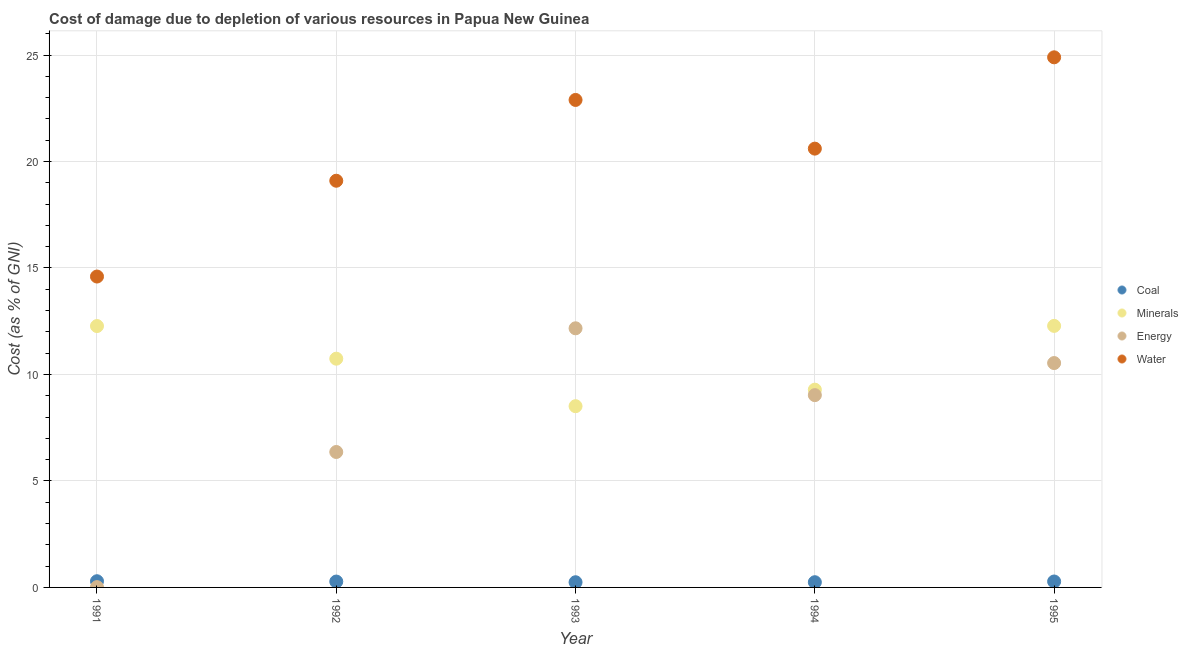What is the cost of damage due to depletion of coal in 1995?
Offer a terse response. 0.28. Across all years, what is the maximum cost of damage due to depletion of water?
Your response must be concise. 24.89. Across all years, what is the minimum cost of damage due to depletion of minerals?
Give a very brief answer. 8.51. What is the total cost of damage due to depletion of energy in the graph?
Provide a succinct answer. 38.11. What is the difference between the cost of damage due to depletion of coal in 1992 and that in 1994?
Provide a short and direct response. 0.03. What is the difference between the cost of damage due to depletion of minerals in 1993 and the cost of damage due to depletion of water in 1991?
Offer a very short reply. -6.09. What is the average cost of damage due to depletion of coal per year?
Your answer should be compact. 0.27. In the year 1994, what is the difference between the cost of damage due to depletion of water and cost of damage due to depletion of coal?
Give a very brief answer. 20.36. What is the ratio of the cost of damage due to depletion of minerals in 1991 to that in 1995?
Keep it short and to the point. 1. Is the difference between the cost of damage due to depletion of water in 1994 and 1995 greater than the difference between the cost of damage due to depletion of minerals in 1994 and 1995?
Your answer should be very brief. No. What is the difference between the highest and the second highest cost of damage due to depletion of minerals?
Your answer should be compact. 0.01. What is the difference between the highest and the lowest cost of damage due to depletion of water?
Your answer should be very brief. 10.29. Is the sum of the cost of damage due to depletion of coal in 1993 and 1994 greater than the maximum cost of damage due to depletion of minerals across all years?
Offer a very short reply. No. Is it the case that in every year, the sum of the cost of damage due to depletion of coal and cost of damage due to depletion of minerals is greater than the cost of damage due to depletion of energy?
Your response must be concise. No. Is the cost of damage due to depletion of coal strictly greater than the cost of damage due to depletion of water over the years?
Provide a short and direct response. No. Is the cost of damage due to depletion of minerals strictly less than the cost of damage due to depletion of coal over the years?
Ensure brevity in your answer.  No. How many dotlines are there?
Your answer should be very brief. 4. How many years are there in the graph?
Offer a very short reply. 5. What is the difference between two consecutive major ticks on the Y-axis?
Offer a very short reply. 5. Are the values on the major ticks of Y-axis written in scientific E-notation?
Make the answer very short. No. Does the graph contain any zero values?
Your response must be concise. No. Does the graph contain grids?
Offer a terse response. Yes. How many legend labels are there?
Provide a short and direct response. 4. What is the title of the graph?
Provide a succinct answer. Cost of damage due to depletion of various resources in Papua New Guinea . Does "Corruption" appear as one of the legend labels in the graph?
Offer a very short reply. No. What is the label or title of the X-axis?
Keep it short and to the point. Year. What is the label or title of the Y-axis?
Provide a short and direct response. Cost (as % of GNI). What is the Cost (as % of GNI) in Coal in 1991?
Offer a terse response. 0.29. What is the Cost (as % of GNI) of Minerals in 1991?
Provide a succinct answer. 12.27. What is the Cost (as % of GNI) in Energy in 1991?
Ensure brevity in your answer.  0.01. What is the Cost (as % of GNI) in Water in 1991?
Provide a short and direct response. 14.6. What is the Cost (as % of GNI) of Coal in 1992?
Offer a very short reply. 0.28. What is the Cost (as % of GNI) of Minerals in 1992?
Ensure brevity in your answer.  10.74. What is the Cost (as % of GNI) of Energy in 1992?
Offer a very short reply. 6.36. What is the Cost (as % of GNI) of Water in 1992?
Keep it short and to the point. 19.1. What is the Cost (as % of GNI) of Coal in 1993?
Your response must be concise. 0.24. What is the Cost (as % of GNI) of Minerals in 1993?
Your response must be concise. 8.51. What is the Cost (as % of GNI) of Energy in 1993?
Keep it short and to the point. 12.17. What is the Cost (as % of GNI) of Water in 1993?
Provide a succinct answer. 22.89. What is the Cost (as % of GNI) in Coal in 1994?
Provide a succinct answer. 0.24. What is the Cost (as % of GNI) of Minerals in 1994?
Your answer should be very brief. 9.29. What is the Cost (as % of GNI) in Energy in 1994?
Make the answer very short. 9.03. What is the Cost (as % of GNI) in Water in 1994?
Keep it short and to the point. 20.6. What is the Cost (as % of GNI) in Coal in 1995?
Offer a terse response. 0.28. What is the Cost (as % of GNI) in Minerals in 1995?
Offer a very short reply. 12.28. What is the Cost (as % of GNI) of Energy in 1995?
Ensure brevity in your answer.  10.54. What is the Cost (as % of GNI) of Water in 1995?
Give a very brief answer. 24.89. Across all years, what is the maximum Cost (as % of GNI) in Coal?
Your response must be concise. 0.29. Across all years, what is the maximum Cost (as % of GNI) of Minerals?
Your answer should be very brief. 12.28. Across all years, what is the maximum Cost (as % of GNI) of Energy?
Your answer should be very brief. 12.17. Across all years, what is the maximum Cost (as % of GNI) of Water?
Keep it short and to the point. 24.89. Across all years, what is the minimum Cost (as % of GNI) of Coal?
Give a very brief answer. 0.24. Across all years, what is the minimum Cost (as % of GNI) of Minerals?
Provide a succinct answer. 8.51. Across all years, what is the minimum Cost (as % of GNI) in Energy?
Offer a terse response. 0.01. Across all years, what is the minimum Cost (as % of GNI) in Water?
Provide a short and direct response. 14.6. What is the total Cost (as % of GNI) of Coal in the graph?
Provide a succinct answer. 1.33. What is the total Cost (as % of GNI) in Minerals in the graph?
Ensure brevity in your answer.  53.09. What is the total Cost (as % of GNI) in Energy in the graph?
Provide a succinct answer. 38.11. What is the total Cost (as % of GNI) of Water in the graph?
Offer a terse response. 102.08. What is the difference between the Cost (as % of GNI) in Coal in 1991 and that in 1992?
Your answer should be compact. 0.02. What is the difference between the Cost (as % of GNI) in Minerals in 1991 and that in 1992?
Make the answer very short. 1.53. What is the difference between the Cost (as % of GNI) of Energy in 1991 and that in 1992?
Give a very brief answer. -6.34. What is the difference between the Cost (as % of GNI) of Water in 1991 and that in 1992?
Provide a succinct answer. -4.5. What is the difference between the Cost (as % of GNI) of Coal in 1991 and that in 1993?
Keep it short and to the point. 0.05. What is the difference between the Cost (as % of GNI) of Minerals in 1991 and that in 1993?
Offer a very short reply. 3.76. What is the difference between the Cost (as % of GNI) in Energy in 1991 and that in 1993?
Keep it short and to the point. -12.15. What is the difference between the Cost (as % of GNI) in Water in 1991 and that in 1993?
Ensure brevity in your answer.  -8.29. What is the difference between the Cost (as % of GNI) in Coal in 1991 and that in 1994?
Offer a very short reply. 0.05. What is the difference between the Cost (as % of GNI) in Minerals in 1991 and that in 1994?
Ensure brevity in your answer.  2.99. What is the difference between the Cost (as % of GNI) in Energy in 1991 and that in 1994?
Offer a terse response. -9.01. What is the difference between the Cost (as % of GNI) in Water in 1991 and that in 1994?
Ensure brevity in your answer.  -6.01. What is the difference between the Cost (as % of GNI) in Coal in 1991 and that in 1995?
Ensure brevity in your answer.  0.01. What is the difference between the Cost (as % of GNI) in Minerals in 1991 and that in 1995?
Offer a very short reply. -0.01. What is the difference between the Cost (as % of GNI) in Energy in 1991 and that in 1995?
Keep it short and to the point. -10.52. What is the difference between the Cost (as % of GNI) of Water in 1991 and that in 1995?
Ensure brevity in your answer.  -10.29. What is the difference between the Cost (as % of GNI) of Coal in 1992 and that in 1993?
Make the answer very short. 0.03. What is the difference between the Cost (as % of GNI) in Minerals in 1992 and that in 1993?
Your answer should be very brief. 2.23. What is the difference between the Cost (as % of GNI) of Energy in 1992 and that in 1993?
Your answer should be compact. -5.81. What is the difference between the Cost (as % of GNI) of Water in 1992 and that in 1993?
Offer a terse response. -3.79. What is the difference between the Cost (as % of GNI) of Coal in 1992 and that in 1994?
Your answer should be very brief. 0.03. What is the difference between the Cost (as % of GNI) in Minerals in 1992 and that in 1994?
Provide a short and direct response. 1.45. What is the difference between the Cost (as % of GNI) in Energy in 1992 and that in 1994?
Provide a succinct answer. -2.67. What is the difference between the Cost (as % of GNI) of Water in 1992 and that in 1994?
Your answer should be compact. -1.51. What is the difference between the Cost (as % of GNI) of Coal in 1992 and that in 1995?
Your response must be concise. -0. What is the difference between the Cost (as % of GNI) in Minerals in 1992 and that in 1995?
Your response must be concise. -1.54. What is the difference between the Cost (as % of GNI) in Energy in 1992 and that in 1995?
Your answer should be very brief. -4.18. What is the difference between the Cost (as % of GNI) in Water in 1992 and that in 1995?
Your response must be concise. -5.8. What is the difference between the Cost (as % of GNI) of Coal in 1993 and that in 1994?
Your answer should be compact. -0. What is the difference between the Cost (as % of GNI) in Minerals in 1993 and that in 1994?
Give a very brief answer. -0.78. What is the difference between the Cost (as % of GNI) in Energy in 1993 and that in 1994?
Offer a very short reply. 3.14. What is the difference between the Cost (as % of GNI) of Water in 1993 and that in 1994?
Make the answer very short. 2.29. What is the difference between the Cost (as % of GNI) of Coal in 1993 and that in 1995?
Provide a succinct answer. -0.04. What is the difference between the Cost (as % of GNI) of Minerals in 1993 and that in 1995?
Keep it short and to the point. -3.77. What is the difference between the Cost (as % of GNI) in Energy in 1993 and that in 1995?
Ensure brevity in your answer.  1.63. What is the difference between the Cost (as % of GNI) in Water in 1993 and that in 1995?
Keep it short and to the point. -2. What is the difference between the Cost (as % of GNI) in Coal in 1994 and that in 1995?
Keep it short and to the point. -0.03. What is the difference between the Cost (as % of GNI) of Minerals in 1994 and that in 1995?
Keep it short and to the point. -2.99. What is the difference between the Cost (as % of GNI) of Energy in 1994 and that in 1995?
Provide a succinct answer. -1.51. What is the difference between the Cost (as % of GNI) of Water in 1994 and that in 1995?
Your answer should be very brief. -4.29. What is the difference between the Cost (as % of GNI) of Coal in 1991 and the Cost (as % of GNI) of Minerals in 1992?
Keep it short and to the point. -10.45. What is the difference between the Cost (as % of GNI) of Coal in 1991 and the Cost (as % of GNI) of Energy in 1992?
Provide a succinct answer. -6.07. What is the difference between the Cost (as % of GNI) in Coal in 1991 and the Cost (as % of GNI) in Water in 1992?
Your answer should be compact. -18.8. What is the difference between the Cost (as % of GNI) of Minerals in 1991 and the Cost (as % of GNI) of Energy in 1992?
Offer a very short reply. 5.91. What is the difference between the Cost (as % of GNI) of Minerals in 1991 and the Cost (as % of GNI) of Water in 1992?
Keep it short and to the point. -6.82. What is the difference between the Cost (as % of GNI) in Energy in 1991 and the Cost (as % of GNI) in Water in 1992?
Make the answer very short. -19.08. What is the difference between the Cost (as % of GNI) of Coal in 1991 and the Cost (as % of GNI) of Minerals in 1993?
Give a very brief answer. -8.22. What is the difference between the Cost (as % of GNI) of Coal in 1991 and the Cost (as % of GNI) of Energy in 1993?
Your answer should be compact. -11.88. What is the difference between the Cost (as % of GNI) in Coal in 1991 and the Cost (as % of GNI) in Water in 1993?
Offer a very short reply. -22.6. What is the difference between the Cost (as % of GNI) in Minerals in 1991 and the Cost (as % of GNI) in Energy in 1993?
Your answer should be very brief. 0.11. What is the difference between the Cost (as % of GNI) in Minerals in 1991 and the Cost (as % of GNI) in Water in 1993?
Provide a short and direct response. -10.62. What is the difference between the Cost (as % of GNI) of Energy in 1991 and the Cost (as % of GNI) of Water in 1993?
Make the answer very short. -22.88. What is the difference between the Cost (as % of GNI) in Coal in 1991 and the Cost (as % of GNI) in Minerals in 1994?
Make the answer very short. -9. What is the difference between the Cost (as % of GNI) in Coal in 1991 and the Cost (as % of GNI) in Energy in 1994?
Your response must be concise. -8.74. What is the difference between the Cost (as % of GNI) of Coal in 1991 and the Cost (as % of GNI) of Water in 1994?
Keep it short and to the point. -20.31. What is the difference between the Cost (as % of GNI) of Minerals in 1991 and the Cost (as % of GNI) of Energy in 1994?
Your answer should be compact. 3.24. What is the difference between the Cost (as % of GNI) in Minerals in 1991 and the Cost (as % of GNI) in Water in 1994?
Make the answer very short. -8.33. What is the difference between the Cost (as % of GNI) in Energy in 1991 and the Cost (as % of GNI) in Water in 1994?
Ensure brevity in your answer.  -20.59. What is the difference between the Cost (as % of GNI) of Coal in 1991 and the Cost (as % of GNI) of Minerals in 1995?
Offer a very short reply. -11.99. What is the difference between the Cost (as % of GNI) of Coal in 1991 and the Cost (as % of GNI) of Energy in 1995?
Make the answer very short. -10.24. What is the difference between the Cost (as % of GNI) of Coal in 1991 and the Cost (as % of GNI) of Water in 1995?
Offer a very short reply. -24.6. What is the difference between the Cost (as % of GNI) in Minerals in 1991 and the Cost (as % of GNI) in Energy in 1995?
Give a very brief answer. 1.74. What is the difference between the Cost (as % of GNI) of Minerals in 1991 and the Cost (as % of GNI) of Water in 1995?
Provide a short and direct response. -12.62. What is the difference between the Cost (as % of GNI) of Energy in 1991 and the Cost (as % of GNI) of Water in 1995?
Offer a terse response. -24.88. What is the difference between the Cost (as % of GNI) of Coal in 1992 and the Cost (as % of GNI) of Minerals in 1993?
Offer a terse response. -8.23. What is the difference between the Cost (as % of GNI) of Coal in 1992 and the Cost (as % of GNI) of Energy in 1993?
Offer a very short reply. -11.89. What is the difference between the Cost (as % of GNI) in Coal in 1992 and the Cost (as % of GNI) in Water in 1993?
Offer a very short reply. -22.61. What is the difference between the Cost (as % of GNI) in Minerals in 1992 and the Cost (as % of GNI) in Energy in 1993?
Offer a terse response. -1.43. What is the difference between the Cost (as % of GNI) of Minerals in 1992 and the Cost (as % of GNI) of Water in 1993?
Offer a terse response. -12.15. What is the difference between the Cost (as % of GNI) in Energy in 1992 and the Cost (as % of GNI) in Water in 1993?
Ensure brevity in your answer.  -16.53. What is the difference between the Cost (as % of GNI) in Coal in 1992 and the Cost (as % of GNI) in Minerals in 1994?
Make the answer very short. -9.01. What is the difference between the Cost (as % of GNI) of Coal in 1992 and the Cost (as % of GNI) of Energy in 1994?
Offer a terse response. -8.75. What is the difference between the Cost (as % of GNI) in Coal in 1992 and the Cost (as % of GNI) in Water in 1994?
Offer a very short reply. -20.33. What is the difference between the Cost (as % of GNI) of Minerals in 1992 and the Cost (as % of GNI) of Energy in 1994?
Your response must be concise. 1.71. What is the difference between the Cost (as % of GNI) of Minerals in 1992 and the Cost (as % of GNI) of Water in 1994?
Provide a short and direct response. -9.86. What is the difference between the Cost (as % of GNI) of Energy in 1992 and the Cost (as % of GNI) of Water in 1994?
Your response must be concise. -14.24. What is the difference between the Cost (as % of GNI) in Coal in 1992 and the Cost (as % of GNI) in Minerals in 1995?
Give a very brief answer. -12. What is the difference between the Cost (as % of GNI) of Coal in 1992 and the Cost (as % of GNI) of Energy in 1995?
Your answer should be very brief. -10.26. What is the difference between the Cost (as % of GNI) of Coal in 1992 and the Cost (as % of GNI) of Water in 1995?
Offer a terse response. -24.62. What is the difference between the Cost (as % of GNI) of Minerals in 1992 and the Cost (as % of GNI) of Energy in 1995?
Your answer should be compact. 0.21. What is the difference between the Cost (as % of GNI) in Minerals in 1992 and the Cost (as % of GNI) in Water in 1995?
Provide a succinct answer. -14.15. What is the difference between the Cost (as % of GNI) in Energy in 1992 and the Cost (as % of GNI) in Water in 1995?
Give a very brief answer. -18.53. What is the difference between the Cost (as % of GNI) of Coal in 1993 and the Cost (as % of GNI) of Minerals in 1994?
Your response must be concise. -9.04. What is the difference between the Cost (as % of GNI) of Coal in 1993 and the Cost (as % of GNI) of Energy in 1994?
Ensure brevity in your answer.  -8.79. What is the difference between the Cost (as % of GNI) in Coal in 1993 and the Cost (as % of GNI) in Water in 1994?
Your answer should be compact. -20.36. What is the difference between the Cost (as % of GNI) of Minerals in 1993 and the Cost (as % of GNI) of Energy in 1994?
Your answer should be compact. -0.52. What is the difference between the Cost (as % of GNI) in Minerals in 1993 and the Cost (as % of GNI) in Water in 1994?
Provide a short and direct response. -12.09. What is the difference between the Cost (as % of GNI) of Energy in 1993 and the Cost (as % of GNI) of Water in 1994?
Your answer should be very brief. -8.44. What is the difference between the Cost (as % of GNI) in Coal in 1993 and the Cost (as % of GNI) in Minerals in 1995?
Give a very brief answer. -12.04. What is the difference between the Cost (as % of GNI) of Coal in 1993 and the Cost (as % of GNI) of Energy in 1995?
Keep it short and to the point. -10.29. What is the difference between the Cost (as % of GNI) in Coal in 1993 and the Cost (as % of GNI) in Water in 1995?
Offer a terse response. -24.65. What is the difference between the Cost (as % of GNI) of Minerals in 1993 and the Cost (as % of GNI) of Energy in 1995?
Your answer should be compact. -2.02. What is the difference between the Cost (as % of GNI) of Minerals in 1993 and the Cost (as % of GNI) of Water in 1995?
Your response must be concise. -16.38. What is the difference between the Cost (as % of GNI) in Energy in 1993 and the Cost (as % of GNI) in Water in 1995?
Make the answer very short. -12.72. What is the difference between the Cost (as % of GNI) of Coal in 1994 and the Cost (as % of GNI) of Minerals in 1995?
Provide a short and direct response. -12.04. What is the difference between the Cost (as % of GNI) of Coal in 1994 and the Cost (as % of GNI) of Energy in 1995?
Your answer should be very brief. -10.29. What is the difference between the Cost (as % of GNI) in Coal in 1994 and the Cost (as % of GNI) in Water in 1995?
Your answer should be compact. -24.65. What is the difference between the Cost (as % of GNI) in Minerals in 1994 and the Cost (as % of GNI) in Energy in 1995?
Make the answer very short. -1.25. What is the difference between the Cost (as % of GNI) in Minerals in 1994 and the Cost (as % of GNI) in Water in 1995?
Ensure brevity in your answer.  -15.61. What is the difference between the Cost (as % of GNI) of Energy in 1994 and the Cost (as % of GNI) of Water in 1995?
Keep it short and to the point. -15.86. What is the average Cost (as % of GNI) of Coal per year?
Provide a succinct answer. 0.27. What is the average Cost (as % of GNI) in Minerals per year?
Offer a very short reply. 10.62. What is the average Cost (as % of GNI) in Energy per year?
Your answer should be compact. 7.62. What is the average Cost (as % of GNI) in Water per year?
Provide a short and direct response. 20.42. In the year 1991, what is the difference between the Cost (as % of GNI) in Coal and Cost (as % of GNI) in Minerals?
Provide a short and direct response. -11.98. In the year 1991, what is the difference between the Cost (as % of GNI) of Coal and Cost (as % of GNI) of Energy?
Give a very brief answer. 0.28. In the year 1991, what is the difference between the Cost (as % of GNI) in Coal and Cost (as % of GNI) in Water?
Give a very brief answer. -14.31. In the year 1991, what is the difference between the Cost (as % of GNI) of Minerals and Cost (as % of GNI) of Energy?
Your response must be concise. 12.26. In the year 1991, what is the difference between the Cost (as % of GNI) of Minerals and Cost (as % of GNI) of Water?
Provide a succinct answer. -2.32. In the year 1991, what is the difference between the Cost (as % of GNI) in Energy and Cost (as % of GNI) in Water?
Your answer should be compact. -14.58. In the year 1992, what is the difference between the Cost (as % of GNI) of Coal and Cost (as % of GNI) of Minerals?
Provide a succinct answer. -10.46. In the year 1992, what is the difference between the Cost (as % of GNI) of Coal and Cost (as % of GNI) of Energy?
Provide a succinct answer. -6.08. In the year 1992, what is the difference between the Cost (as % of GNI) in Coal and Cost (as % of GNI) in Water?
Provide a succinct answer. -18.82. In the year 1992, what is the difference between the Cost (as % of GNI) of Minerals and Cost (as % of GNI) of Energy?
Ensure brevity in your answer.  4.38. In the year 1992, what is the difference between the Cost (as % of GNI) of Minerals and Cost (as % of GNI) of Water?
Offer a very short reply. -8.36. In the year 1992, what is the difference between the Cost (as % of GNI) of Energy and Cost (as % of GNI) of Water?
Your response must be concise. -12.74. In the year 1993, what is the difference between the Cost (as % of GNI) of Coal and Cost (as % of GNI) of Minerals?
Offer a terse response. -8.27. In the year 1993, what is the difference between the Cost (as % of GNI) of Coal and Cost (as % of GNI) of Energy?
Keep it short and to the point. -11.92. In the year 1993, what is the difference between the Cost (as % of GNI) in Coal and Cost (as % of GNI) in Water?
Your answer should be very brief. -22.65. In the year 1993, what is the difference between the Cost (as % of GNI) in Minerals and Cost (as % of GNI) in Energy?
Provide a succinct answer. -3.66. In the year 1993, what is the difference between the Cost (as % of GNI) in Minerals and Cost (as % of GNI) in Water?
Offer a very short reply. -14.38. In the year 1993, what is the difference between the Cost (as % of GNI) of Energy and Cost (as % of GNI) of Water?
Keep it short and to the point. -10.72. In the year 1994, what is the difference between the Cost (as % of GNI) of Coal and Cost (as % of GNI) of Minerals?
Offer a very short reply. -9.04. In the year 1994, what is the difference between the Cost (as % of GNI) of Coal and Cost (as % of GNI) of Energy?
Keep it short and to the point. -8.78. In the year 1994, what is the difference between the Cost (as % of GNI) in Coal and Cost (as % of GNI) in Water?
Your response must be concise. -20.36. In the year 1994, what is the difference between the Cost (as % of GNI) of Minerals and Cost (as % of GNI) of Energy?
Your answer should be very brief. 0.26. In the year 1994, what is the difference between the Cost (as % of GNI) in Minerals and Cost (as % of GNI) in Water?
Offer a terse response. -11.32. In the year 1994, what is the difference between the Cost (as % of GNI) in Energy and Cost (as % of GNI) in Water?
Provide a succinct answer. -11.57. In the year 1995, what is the difference between the Cost (as % of GNI) of Coal and Cost (as % of GNI) of Minerals?
Provide a short and direct response. -12. In the year 1995, what is the difference between the Cost (as % of GNI) in Coal and Cost (as % of GNI) in Energy?
Offer a very short reply. -10.26. In the year 1995, what is the difference between the Cost (as % of GNI) in Coal and Cost (as % of GNI) in Water?
Ensure brevity in your answer.  -24.61. In the year 1995, what is the difference between the Cost (as % of GNI) of Minerals and Cost (as % of GNI) of Energy?
Your answer should be very brief. 1.75. In the year 1995, what is the difference between the Cost (as % of GNI) of Minerals and Cost (as % of GNI) of Water?
Your answer should be very brief. -12.61. In the year 1995, what is the difference between the Cost (as % of GNI) of Energy and Cost (as % of GNI) of Water?
Your answer should be very brief. -14.36. What is the ratio of the Cost (as % of GNI) of Coal in 1991 to that in 1992?
Make the answer very short. 1.06. What is the ratio of the Cost (as % of GNI) in Minerals in 1991 to that in 1992?
Give a very brief answer. 1.14. What is the ratio of the Cost (as % of GNI) in Energy in 1991 to that in 1992?
Your answer should be very brief. 0. What is the ratio of the Cost (as % of GNI) of Water in 1991 to that in 1992?
Provide a succinct answer. 0.76. What is the ratio of the Cost (as % of GNI) in Coal in 1991 to that in 1993?
Provide a short and direct response. 1.2. What is the ratio of the Cost (as % of GNI) of Minerals in 1991 to that in 1993?
Provide a short and direct response. 1.44. What is the ratio of the Cost (as % of GNI) of Energy in 1991 to that in 1993?
Keep it short and to the point. 0. What is the ratio of the Cost (as % of GNI) of Water in 1991 to that in 1993?
Provide a short and direct response. 0.64. What is the ratio of the Cost (as % of GNI) in Coal in 1991 to that in 1994?
Offer a very short reply. 1.19. What is the ratio of the Cost (as % of GNI) in Minerals in 1991 to that in 1994?
Give a very brief answer. 1.32. What is the ratio of the Cost (as % of GNI) of Energy in 1991 to that in 1994?
Provide a succinct answer. 0. What is the ratio of the Cost (as % of GNI) in Water in 1991 to that in 1994?
Your answer should be very brief. 0.71. What is the ratio of the Cost (as % of GNI) in Coal in 1991 to that in 1995?
Your answer should be very brief. 1.04. What is the ratio of the Cost (as % of GNI) of Energy in 1991 to that in 1995?
Keep it short and to the point. 0. What is the ratio of the Cost (as % of GNI) of Water in 1991 to that in 1995?
Give a very brief answer. 0.59. What is the ratio of the Cost (as % of GNI) in Coal in 1992 to that in 1993?
Offer a very short reply. 1.13. What is the ratio of the Cost (as % of GNI) in Minerals in 1992 to that in 1993?
Your answer should be compact. 1.26. What is the ratio of the Cost (as % of GNI) of Energy in 1992 to that in 1993?
Your answer should be compact. 0.52. What is the ratio of the Cost (as % of GNI) in Water in 1992 to that in 1993?
Make the answer very short. 0.83. What is the ratio of the Cost (as % of GNI) of Coal in 1992 to that in 1994?
Offer a terse response. 1.13. What is the ratio of the Cost (as % of GNI) in Minerals in 1992 to that in 1994?
Your answer should be very brief. 1.16. What is the ratio of the Cost (as % of GNI) of Energy in 1992 to that in 1994?
Keep it short and to the point. 0.7. What is the ratio of the Cost (as % of GNI) in Water in 1992 to that in 1994?
Your response must be concise. 0.93. What is the ratio of the Cost (as % of GNI) in Minerals in 1992 to that in 1995?
Ensure brevity in your answer.  0.87. What is the ratio of the Cost (as % of GNI) in Energy in 1992 to that in 1995?
Provide a short and direct response. 0.6. What is the ratio of the Cost (as % of GNI) of Water in 1992 to that in 1995?
Your answer should be very brief. 0.77. What is the ratio of the Cost (as % of GNI) in Minerals in 1993 to that in 1994?
Offer a very short reply. 0.92. What is the ratio of the Cost (as % of GNI) in Energy in 1993 to that in 1994?
Your answer should be compact. 1.35. What is the ratio of the Cost (as % of GNI) of Water in 1993 to that in 1994?
Ensure brevity in your answer.  1.11. What is the ratio of the Cost (as % of GNI) of Coal in 1993 to that in 1995?
Provide a succinct answer. 0.87. What is the ratio of the Cost (as % of GNI) of Minerals in 1993 to that in 1995?
Provide a short and direct response. 0.69. What is the ratio of the Cost (as % of GNI) in Energy in 1993 to that in 1995?
Your answer should be very brief. 1.15. What is the ratio of the Cost (as % of GNI) in Water in 1993 to that in 1995?
Give a very brief answer. 0.92. What is the ratio of the Cost (as % of GNI) in Coal in 1994 to that in 1995?
Provide a short and direct response. 0.88. What is the ratio of the Cost (as % of GNI) in Minerals in 1994 to that in 1995?
Offer a very short reply. 0.76. What is the ratio of the Cost (as % of GNI) of Energy in 1994 to that in 1995?
Provide a short and direct response. 0.86. What is the ratio of the Cost (as % of GNI) of Water in 1994 to that in 1995?
Make the answer very short. 0.83. What is the difference between the highest and the second highest Cost (as % of GNI) of Coal?
Make the answer very short. 0.01. What is the difference between the highest and the second highest Cost (as % of GNI) of Minerals?
Make the answer very short. 0.01. What is the difference between the highest and the second highest Cost (as % of GNI) of Energy?
Provide a succinct answer. 1.63. What is the difference between the highest and the second highest Cost (as % of GNI) in Water?
Provide a short and direct response. 2. What is the difference between the highest and the lowest Cost (as % of GNI) in Coal?
Ensure brevity in your answer.  0.05. What is the difference between the highest and the lowest Cost (as % of GNI) in Minerals?
Make the answer very short. 3.77. What is the difference between the highest and the lowest Cost (as % of GNI) in Energy?
Offer a very short reply. 12.15. What is the difference between the highest and the lowest Cost (as % of GNI) of Water?
Your response must be concise. 10.29. 